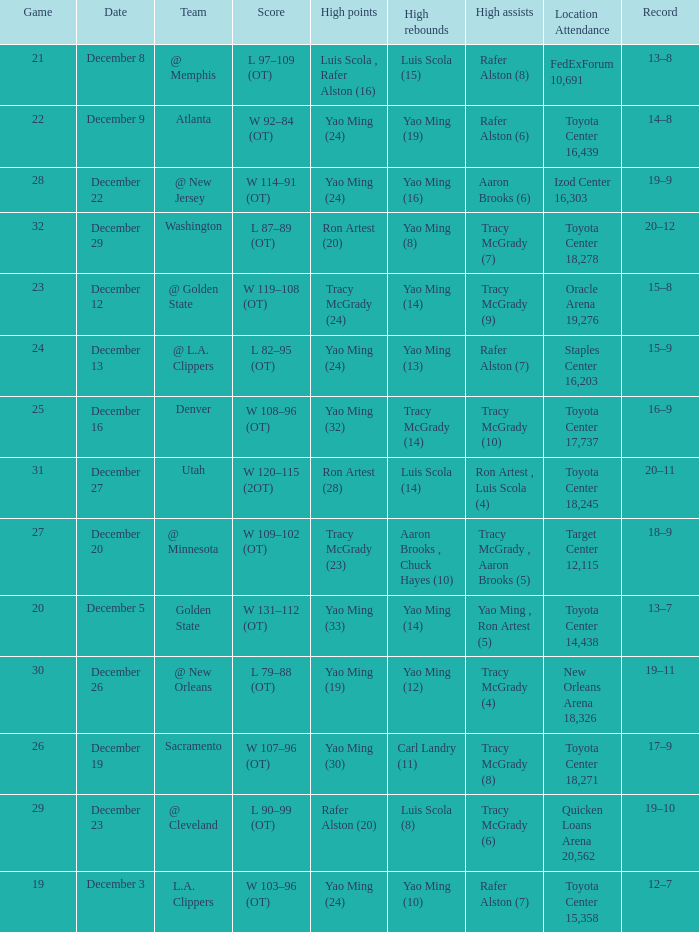When @ new orleans is the team who has the highest amount of rebounds? Yao Ming (12). 